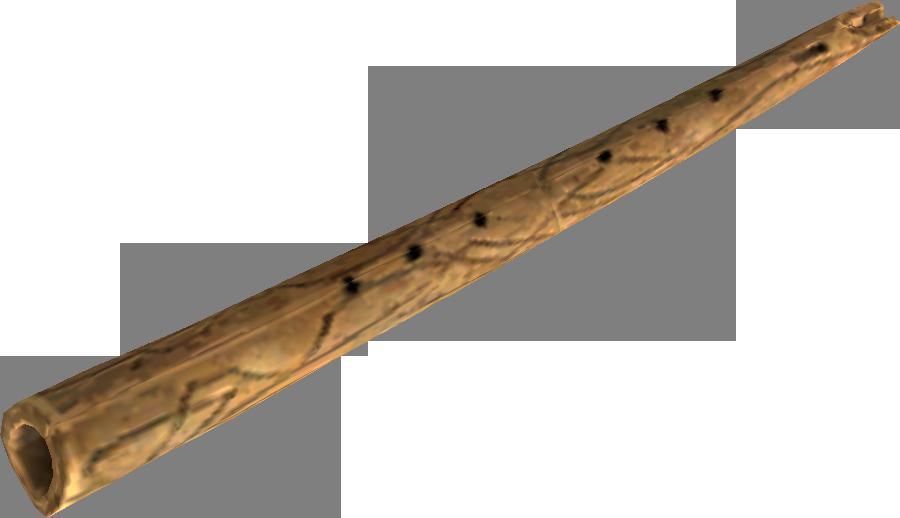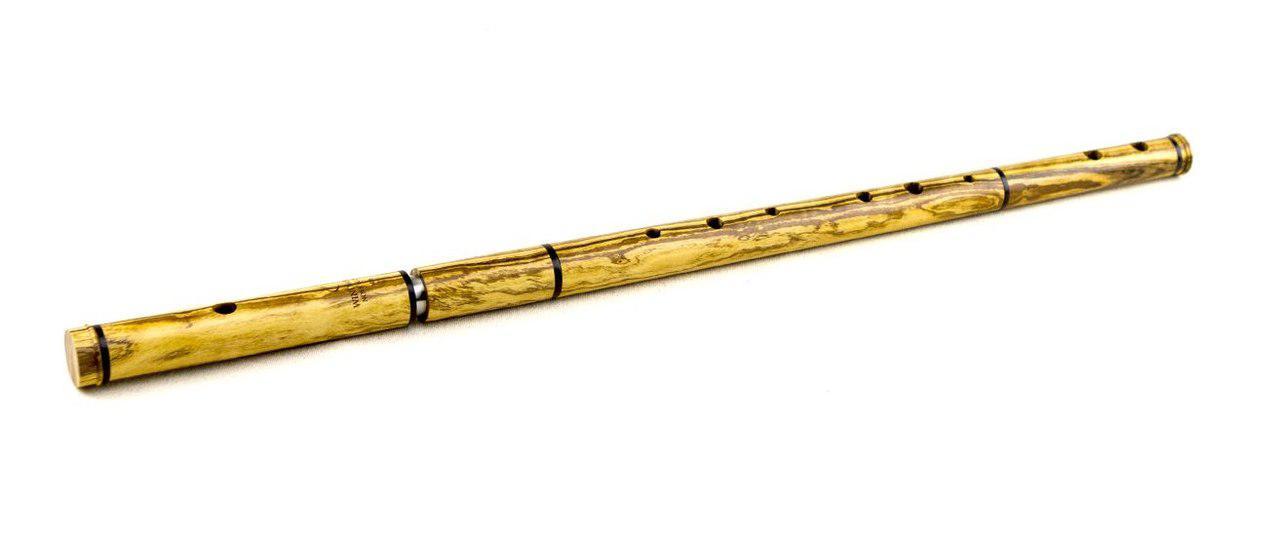The first image is the image on the left, the second image is the image on the right. Given the left and right images, does the statement "Both flutes are angled from bottom left to top right." hold true? Answer yes or no. Yes. The first image is the image on the left, the second image is the image on the right. Considering the images on both sides, is "The flutes displayed on the left and right angle toward each other, and the flute on the right is decorated with tribal motifs." valid? Answer yes or no. No. 